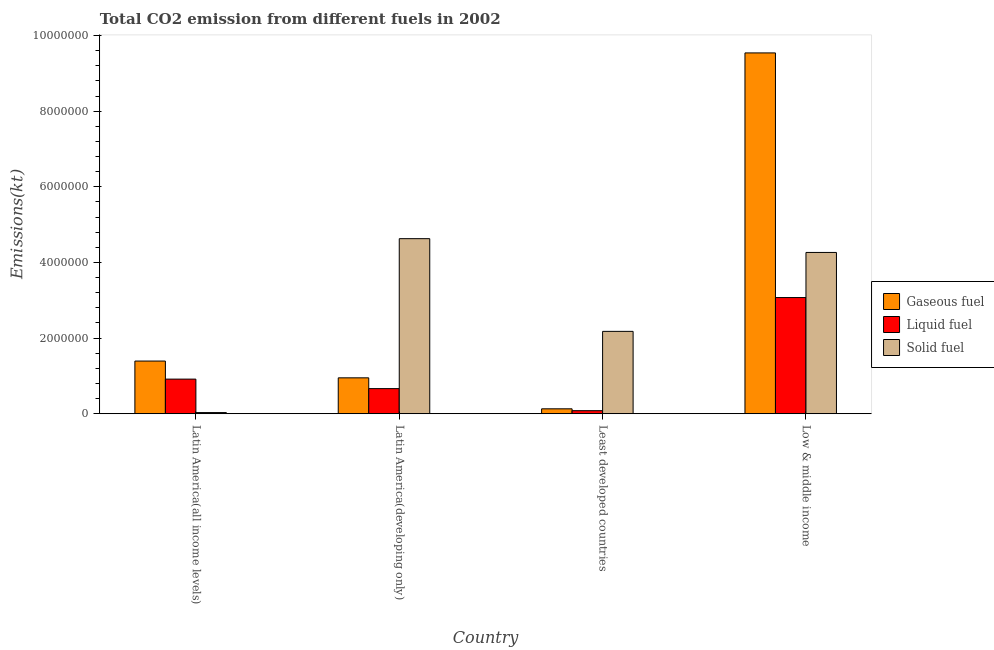How many different coloured bars are there?
Make the answer very short. 3. How many groups of bars are there?
Give a very brief answer. 4. In how many cases, is the number of bars for a given country not equal to the number of legend labels?
Make the answer very short. 0. What is the amount of co2 emissions from liquid fuel in Latin America(developing only)?
Provide a short and direct response. 6.64e+05. Across all countries, what is the maximum amount of co2 emissions from gaseous fuel?
Provide a succinct answer. 9.54e+06. Across all countries, what is the minimum amount of co2 emissions from liquid fuel?
Give a very brief answer. 8.08e+04. In which country was the amount of co2 emissions from solid fuel maximum?
Your answer should be compact. Latin America(developing only). In which country was the amount of co2 emissions from liquid fuel minimum?
Give a very brief answer. Least developed countries. What is the total amount of co2 emissions from gaseous fuel in the graph?
Offer a terse response. 1.20e+07. What is the difference between the amount of co2 emissions from liquid fuel in Latin America(developing only) and that in Low & middle income?
Provide a short and direct response. -2.41e+06. What is the difference between the amount of co2 emissions from solid fuel in Low & middle income and the amount of co2 emissions from gaseous fuel in Least developed countries?
Offer a terse response. 4.13e+06. What is the average amount of co2 emissions from liquid fuel per country?
Provide a succinct answer. 1.18e+06. What is the difference between the amount of co2 emissions from gaseous fuel and amount of co2 emissions from liquid fuel in Least developed countries?
Your answer should be compact. 4.94e+04. In how many countries, is the amount of co2 emissions from solid fuel greater than 800000 kt?
Ensure brevity in your answer.  3. What is the ratio of the amount of co2 emissions from gaseous fuel in Latin America(all income levels) to that in Latin America(developing only)?
Offer a terse response. 1.47. What is the difference between the highest and the second highest amount of co2 emissions from liquid fuel?
Your answer should be very brief. 2.16e+06. What is the difference between the highest and the lowest amount of co2 emissions from gaseous fuel?
Offer a terse response. 9.41e+06. In how many countries, is the amount of co2 emissions from gaseous fuel greater than the average amount of co2 emissions from gaseous fuel taken over all countries?
Provide a succinct answer. 1. Is the sum of the amount of co2 emissions from solid fuel in Latin America(all income levels) and Low & middle income greater than the maximum amount of co2 emissions from liquid fuel across all countries?
Ensure brevity in your answer.  Yes. What does the 1st bar from the left in Low & middle income represents?
Make the answer very short. Gaseous fuel. What does the 1st bar from the right in Latin America(developing only) represents?
Give a very brief answer. Solid fuel. Is it the case that in every country, the sum of the amount of co2 emissions from gaseous fuel and amount of co2 emissions from liquid fuel is greater than the amount of co2 emissions from solid fuel?
Offer a very short reply. No. Are all the bars in the graph horizontal?
Keep it short and to the point. No. What is the difference between two consecutive major ticks on the Y-axis?
Your answer should be very brief. 2.00e+06. Does the graph contain any zero values?
Make the answer very short. No. Does the graph contain grids?
Your answer should be very brief. No. Where does the legend appear in the graph?
Offer a very short reply. Center right. How many legend labels are there?
Provide a succinct answer. 3. What is the title of the graph?
Provide a succinct answer. Total CO2 emission from different fuels in 2002. What is the label or title of the Y-axis?
Keep it short and to the point. Emissions(kt). What is the Emissions(kt) in Gaseous fuel in Latin America(all income levels)?
Your answer should be compact. 1.39e+06. What is the Emissions(kt) of Liquid fuel in Latin America(all income levels)?
Make the answer very short. 9.15e+05. What is the Emissions(kt) of Solid fuel in Latin America(all income levels)?
Offer a very short reply. 3.10e+04. What is the Emissions(kt) in Gaseous fuel in Latin America(developing only)?
Your response must be concise. 9.49e+05. What is the Emissions(kt) of Liquid fuel in Latin America(developing only)?
Keep it short and to the point. 6.64e+05. What is the Emissions(kt) in Solid fuel in Latin America(developing only)?
Make the answer very short. 4.63e+06. What is the Emissions(kt) of Gaseous fuel in Least developed countries?
Your answer should be compact. 1.30e+05. What is the Emissions(kt) of Liquid fuel in Least developed countries?
Provide a succinct answer. 8.08e+04. What is the Emissions(kt) of Solid fuel in Least developed countries?
Ensure brevity in your answer.  2.18e+06. What is the Emissions(kt) of Gaseous fuel in Low & middle income?
Make the answer very short. 9.54e+06. What is the Emissions(kt) in Liquid fuel in Low & middle income?
Offer a very short reply. 3.07e+06. What is the Emissions(kt) in Solid fuel in Low & middle income?
Your answer should be compact. 4.26e+06. Across all countries, what is the maximum Emissions(kt) in Gaseous fuel?
Ensure brevity in your answer.  9.54e+06. Across all countries, what is the maximum Emissions(kt) of Liquid fuel?
Your answer should be very brief. 3.07e+06. Across all countries, what is the maximum Emissions(kt) in Solid fuel?
Your response must be concise. 4.63e+06. Across all countries, what is the minimum Emissions(kt) in Gaseous fuel?
Ensure brevity in your answer.  1.30e+05. Across all countries, what is the minimum Emissions(kt) of Liquid fuel?
Make the answer very short. 8.08e+04. Across all countries, what is the minimum Emissions(kt) in Solid fuel?
Your answer should be compact. 3.10e+04. What is the total Emissions(kt) of Gaseous fuel in the graph?
Offer a terse response. 1.20e+07. What is the total Emissions(kt) of Liquid fuel in the graph?
Keep it short and to the point. 4.73e+06. What is the total Emissions(kt) in Solid fuel in the graph?
Your answer should be very brief. 1.11e+07. What is the difference between the Emissions(kt) in Gaseous fuel in Latin America(all income levels) and that in Latin America(developing only)?
Offer a very short reply. 4.44e+05. What is the difference between the Emissions(kt) of Liquid fuel in Latin America(all income levels) and that in Latin America(developing only)?
Keep it short and to the point. 2.51e+05. What is the difference between the Emissions(kt) of Solid fuel in Latin America(all income levels) and that in Latin America(developing only)?
Provide a short and direct response. -4.60e+06. What is the difference between the Emissions(kt) of Gaseous fuel in Latin America(all income levels) and that in Least developed countries?
Your answer should be compact. 1.26e+06. What is the difference between the Emissions(kt) in Liquid fuel in Latin America(all income levels) and that in Least developed countries?
Your answer should be compact. 8.35e+05. What is the difference between the Emissions(kt) of Solid fuel in Latin America(all income levels) and that in Least developed countries?
Provide a succinct answer. -2.15e+06. What is the difference between the Emissions(kt) in Gaseous fuel in Latin America(all income levels) and that in Low & middle income?
Offer a terse response. -8.15e+06. What is the difference between the Emissions(kt) of Liquid fuel in Latin America(all income levels) and that in Low & middle income?
Make the answer very short. -2.16e+06. What is the difference between the Emissions(kt) of Solid fuel in Latin America(all income levels) and that in Low & middle income?
Provide a succinct answer. -4.23e+06. What is the difference between the Emissions(kt) of Gaseous fuel in Latin America(developing only) and that in Least developed countries?
Make the answer very short. 8.19e+05. What is the difference between the Emissions(kt) in Liquid fuel in Latin America(developing only) and that in Least developed countries?
Offer a very short reply. 5.83e+05. What is the difference between the Emissions(kt) in Solid fuel in Latin America(developing only) and that in Least developed countries?
Make the answer very short. 2.45e+06. What is the difference between the Emissions(kt) of Gaseous fuel in Latin America(developing only) and that in Low & middle income?
Provide a short and direct response. -8.59e+06. What is the difference between the Emissions(kt) of Liquid fuel in Latin America(developing only) and that in Low & middle income?
Your response must be concise. -2.41e+06. What is the difference between the Emissions(kt) of Solid fuel in Latin America(developing only) and that in Low & middle income?
Your answer should be very brief. 3.64e+05. What is the difference between the Emissions(kt) of Gaseous fuel in Least developed countries and that in Low & middle income?
Keep it short and to the point. -9.41e+06. What is the difference between the Emissions(kt) in Liquid fuel in Least developed countries and that in Low & middle income?
Ensure brevity in your answer.  -2.99e+06. What is the difference between the Emissions(kt) of Solid fuel in Least developed countries and that in Low & middle income?
Keep it short and to the point. -2.09e+06. What is the difference between the Emissions(kt) in Gaseous fuel in Latin America(all income levels) and the Emissions(kt) in Liquid fuel in Latin America(developing only)?
Make the answer very short. 7.29e+05. What is the difference between the Emissions(kt) of Gaseous fuel in Latin America(all income levels) and the Emissions(kt) of Solid fuel in Latin America(developing only)?
Provide a short and direct response. -3.24e+06. What is the difference between the Emissions(kt) of Liquid fuel in Latin America(all income levels) and the Emissions(kt) of Solid fuel in Latin America(developing only)?
Your response must be concise. -3.71e+06. What is the difference between the Emissions(kt) of Gaseous fuel in Latin America(all income levels) and the Emissions(kt) of Liquid fuel in Least developed countries?
Offer a terse response. 1.31e+06. What is the difference between the Emissions(kt) in Gaseous fuel in Latin America(all income levels) and the Emissions(kt) in Solid fuel in Least developed countries?
Make the answer very short. -7.85e+05. What is the difference between the Emissions(kt) in Liquid fuel in Latin America(all income levels) and the Emissions(kt) in Solid fuel in Least developed countries?
Offer a very short reply. -1.26e+06. What is the difference between the Emissions(kt) of Gaseous fuel in Latin America(all income levels) and the Emissions(kt) of Liquid fuel in Low & middle income?
Ensure brevity in your answer.  -1.68e+06. What is the difference between the Emissions(kt) of Gaseous fuel in Latin America(all income levels) and the Emissions(kt) of Solid fuel in Low & middle income?
Your response must be concise. -2.87e+06. What is the difference between the Emissions(kt) in Liquid fuel in Latin America(all income levels) and the Emissions(kt) in Solid fuel in Low & middle income?
Your answer should be very brief. -3.35e+06. What is the difference between the Emissions(kt) in Gaseous fuel in Latin America(developing only) and the Emissions(kt) in Liquid fuel in Least developed countries?
Keep it short and to the point. 8.68e+05. What is the difference between the Emissions(kt) in Gaseous fuel in Latin America(developing only) and the Emissions(kt) in Solid fuel in Least developed countries?
Provide a succinct answer. -1.23e+06. What is the difference between the Emissions(kt) of Liquid fuel in Latin America(developing only) and the Emissions(kt) of Solid fuel in Least developed countries?
Your response must be concise. -1.51e+06. What is the difference between the Emissions(kt) in Gaseous fuel in Latin America(developing only) and the Emissions(kt) in Liquid fuel in Low & middle income?
Your response must be concise. -2.12e+06. What is the difference between the Emissions(kt) in Gaseous fuel in Latin America(developing only) and the Emissions(kt) in Solid fuel in Low & middle income?
Keep it short and to the point. -3.32e+06. What is the difference between the Emissions(kt) of Liquid fuel in Latin America(developing only) and the Emissions(kt) of Solid fuel in Low & middle income?
Offer a terse response. -3.60e+06. What is the difference between the Emissions(kt) in Gaseous fuel in Least developed countries and the Emissions(kt) in Liquid fuel in Low & middle income?
Offer a terse response. -2.94e+06. What is the difference between the Emissions(kt) of Gaseous fuel in Least developed countries and the Emissions(kt) of Solid fuel in Low & middle income?
Provide a succinct answer. -4.13e+06. What is the difference between the Emissions(kt) in Liquid fuel in Least developed countries and the Emissions(kt) in Solid fuel in Low & middle income?
Your answer should be compact. -4.18e+06. What is the average Emissions(kt) of Gaseous fuel per country?
Your answer should be very brief. 3.00e+06. What is the average Emissions(kt) of Liquid fuel per country?
Offer a very short reply. 1.18e+06. What is the average Emissions(kt) of Solid fuel per country?
Your answer should be compact. 2.78e+06. What is the difference between the Emissions(kt) in Gaseous fuel and Emissions(kt) in Liquid fuel in Latin America(all income levels)?
Your response must be concise. 4.78e+05. What is the difference between the Emissions(kt) in Gaseous fuel and Emissions(kt) in Solid fuel in Latin America(all income levels)?
Provide a short and direct response. 1.36e+06. What is the difference between the Emissions(kt) in Liquid fuel and Emissions(kt) in Solid fuel in Latin America(all income levels)?
Keep it short and to the point. 8.84e+05. What is the difference between the Emissions(kt) of Gaseous fuel and Emissions(kt) of Liquid fuel in Latin America(developing only)?
Keep it short and to the point. 2.85e+05. What is the difference between the Emissions(kt) in Gaseous fuel and Emissions(kt) in Solid fuel in Latin America(developing only)?
Your response must be concise. -3.68e+06. What is the difference between the Emissions(kt) in Liquid fuel and Emissions(kt) in Solid fuel in Latin America(developing only)?
Provide a short and direct response. -3.96e+06. What is the difference between the Emissions(kt) in Gaseous fuel and Emissions(kt) in Liquid fuel in Least developed countries?
Ensure brevity in your answer.  4.94e+04. What is the difference between the Emissions(kt) in Gaseous fuel and Emissions(kt) in Solid fuel in Least developed countries?
Provide a succinct answer. -2.05e+06. What is the difference between the Emissions(kt) in Liquid fuel and Emissions(kt) in Solid fuel in Least developed countries?
Offer a terse response. -2.10e+06. What is the difference between the Emissions(kt) of Gaseous fuel and Emissions(kt) of Liquid fuel in Low & middle income?
Offer a terse response. 6.47e+06. What is the difference between the Emissions(kt) in Gaseous fuel and Emissions(kt) in Solid fuel in Low & middle income?
Your answer should be very brief. 5.28e+06. What is the difference between the Emissions(kt) in Liquid fuel and Emissions(kt) in Solid fuel in Low & middle income?
Provide a short and direct response. -1.19e+06. What is the ratio of the Emissions(kt) of Gaseous fuel in Latin America(all income levels) to that in Latin America(developing only)?
Your response must be concise. 1.47. What is the ratio of the Emissions(kt) of Liquid fuel in Latin America(all income levels) to that in Latin America(developing only)?
Offer a very short reply. 1.38. What is the ratio of the Emissions(kt) of Solid fuel in Latin America(all income levels) to that in Latin America(developing only)?
Provide a short and direct response. 0.01. What is the ratio of the Emissions(kt) of Gaseous fuel in Latin America(all income levels) to that in Least developed countries?
Offer a terse response. 10.7. What is the ratio of the Emissions(kt) in Liquid fuel in Latin America(all income levels) to that in Least developed countries?
Provide a succinct answer. 11.33. What is the ratio of the Emissions(kt) of Solid fuel in Latin America(all income levels) to that in Least developed countries?
Your answer should be compact. 0.01. What is the ratio of the Emissions(kt) in Gaseous fuel in Latin America(all income levels) to that in Low & middle income?
Keep it short and to the point. 0.15. What is the ratio of the Emissions(kt) in Liquid fuel in Latin America(all income levels) to that in Low & middle income?
Keep it short and to the point. 0.3. What is the ratio of the Emissions(kt) in Solid fuel in Latin America(all income levels) to that in Low & middle income?
Provide a short and direct response. 0.01. What is the ratio of the Emissions(kt) of Gaseous fuel in Latin America(developing only) to that in Least developed countries?
Give a very brief answer. 7.29. What is the ratio of the Emissions(kt) in Liquid fuel in Latin America(developing only) to that in Least developed countries?
Ensure brevity in your answer.  8.22. What is the ratio of the Emissions(kt) of Solid fuel in Latin America(developing only) to that in Least developed countries?
Your answer should be compact. 2.13. What is the ratio of the Emissions(kt) in Gaseous fuel in Latin America(developing only) to that in Low & middle income?
Provide a short and direct response. 0.1. What is the ratio of the Emissions(kt) in Liquid fuel in Latin America(developing only) to that in Low & middle income?
Ensure brevity in your answer.  0.22. What is the ratio of the Emissions(kt) of Solid fuel in Latin America(developing only) to that in Low & middle income?
Offer a terse response. 1.09. What is the ratio of the Emissions(kt) in Gaseous fuel in Least developed countries to that in Low & middle income?
Make the answer very short. 0.01. What is the ratio of the Emissions(kt) of Liquid fuel in Least developed countries to that in Low & middle income?
Give a very brief answer. 0.03. What is the ratio of the Emissions(kt) of Solid fuel in Least developed countries to that in Low & middle income?
Ensure brevity in your answer.  0.51. What is the difference between the highest and the second highest Emissions(kt) in Gaseous fuel?
Your answer should be compact. 8.15e+06. What is the difference between the highest and the second highest Emissions(kt) of Liquid fuel?
Give a very brief answer. 2.16e+06. What is the difference between the highest and the second highest Emissions(kt) in Solid fuel?
Offer a terse response. 3.64e+05. What is the difference between the highest and the lowest Emissions(kt) in Gaseous fuel?
Offer a terse response. 9.41e+06. What is the difference between the highest and the lowest Emissions(kt) of Liquid fuel?
Your response must be concise. 2.99e+06. What is the difference between the highest and the lowest Emissions(kt) of Solid fuel?
Make the answer very short. 4.60e+06. 